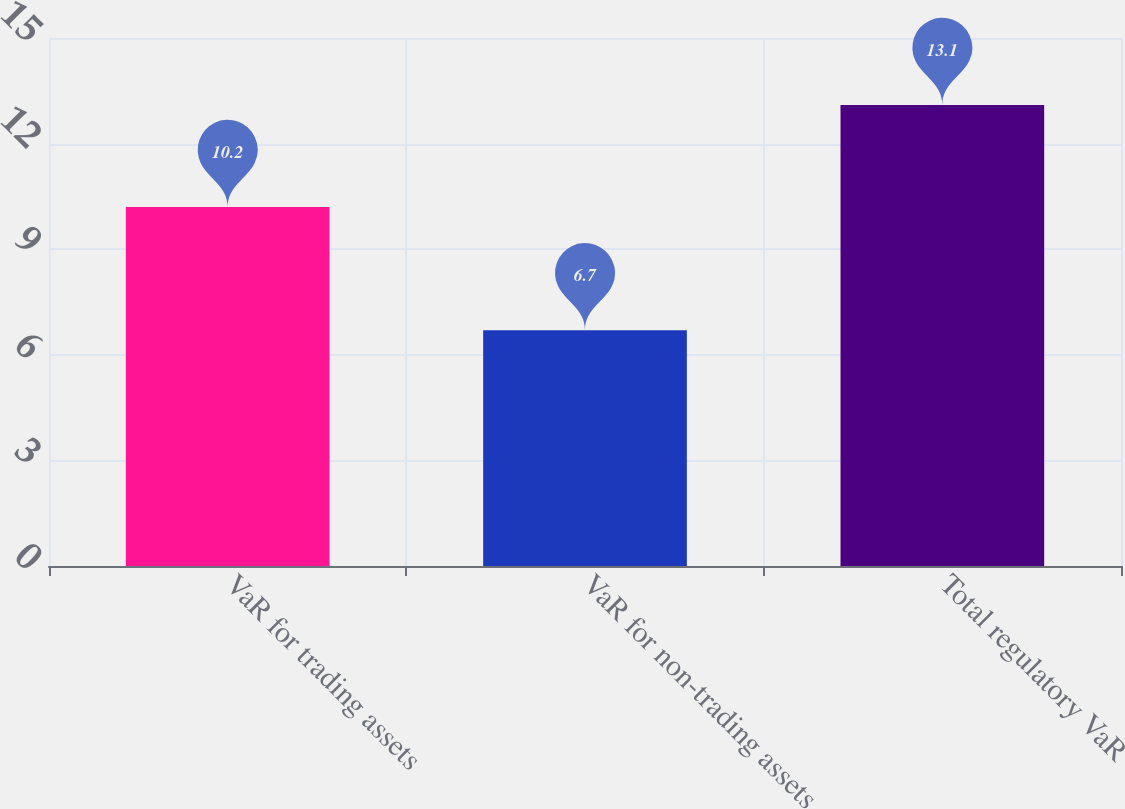Convert chart. <chart><loc_0><loc_0><loc_500><loc_500><bar_chart><fcel>VaR for trading assets<fcel>VaR for non-trading assets<fcel>Total regulatory VaR<nl><fcel>10.2<fcel>6.7<fcel>13.1<nl></chart> 